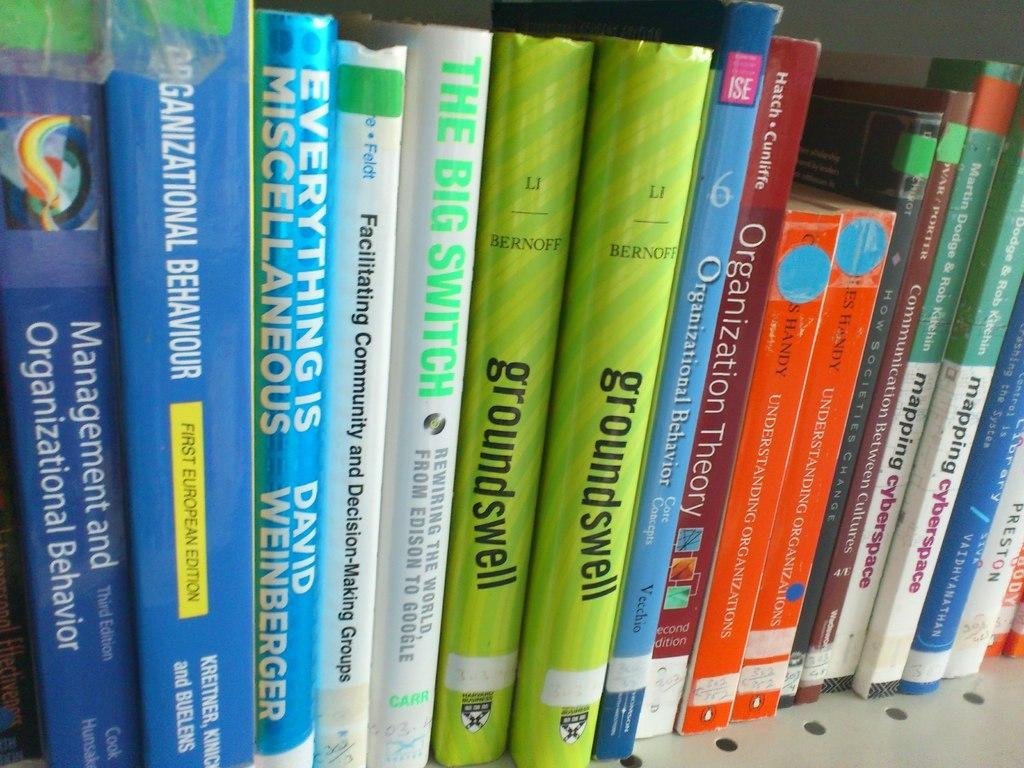<image>
Create a compact narrative representing the image presented. Groundswell book, Understanding Organizations, and Management and Organizational Behavior. 